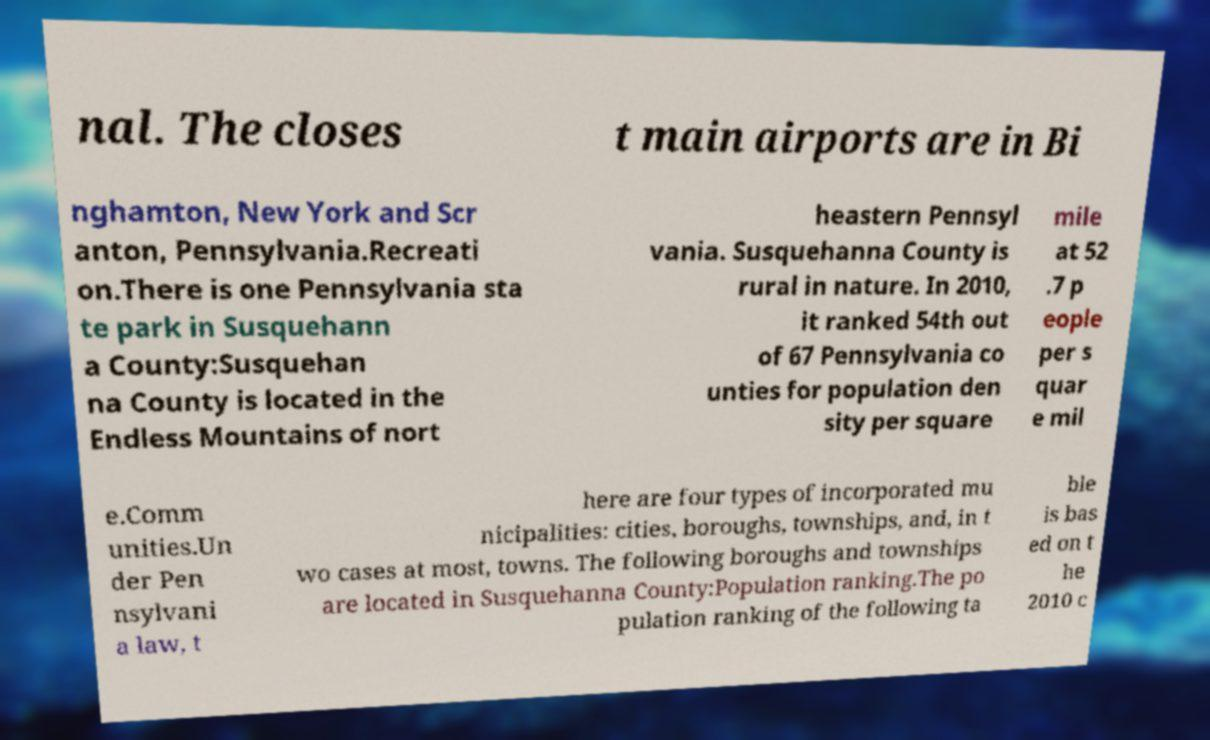Can you accurately transcribe the text from the provided image for me? nal. The closes t main airports are in Bi nghamton, New York and Scr anton, Pennsylvania.Recreati on.There is one Pennsylvania sta te park in Susquehann a County:Susquehan na County is located in the Endless Mountains of nort heastern Pennsyl vania. Susquehanna County is rural in nature. In 2010, it ranked 54th out of 67 Pennsylvania co unties for population den sity per square mile at 52 .7 p eople per s quar e mil e.Comm unities.Un der Pen nsylvani a law, t here are four types of incorporated mu nicipalities: cities, boroughs, townships, and, in t wo cases at most, towns. The following boroughs and townships are located in Susquehanna County:Population ranking.The po pulation ranking of the following ta ble is bas ed on t he 2010 c 